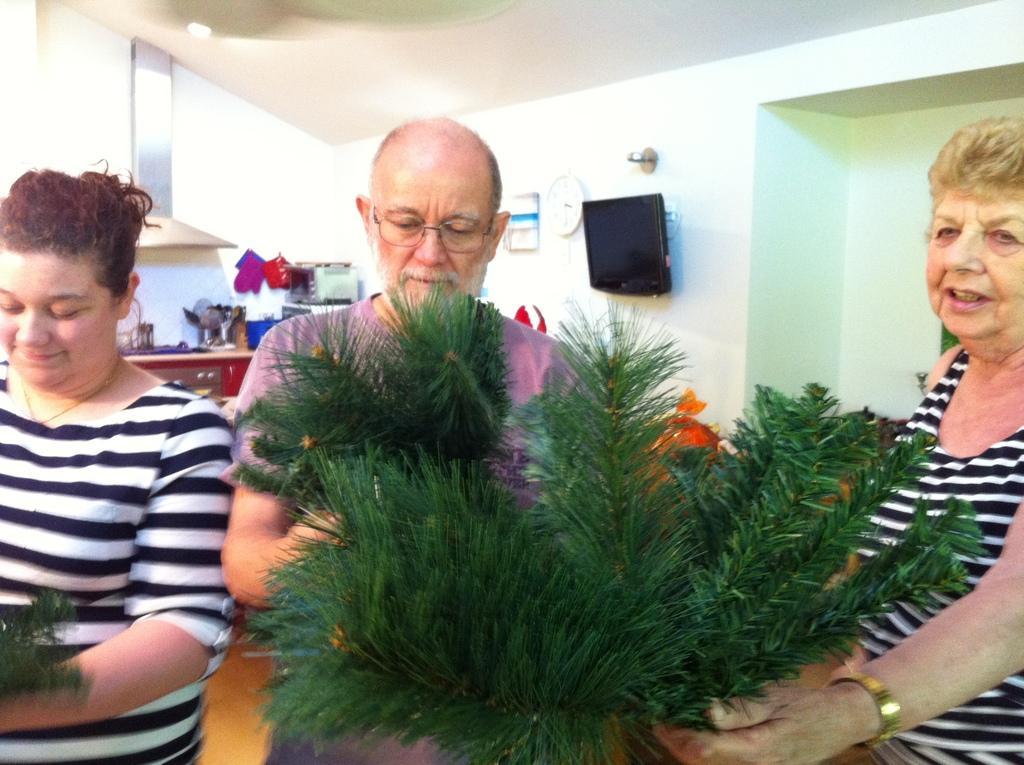Describe this image in one or two sentences. In this image I can see three persons standing. In front the person is holding few plants. In the background I can see few objects on the counter top and I can also see the television attached to the wall and the wall is in white color. 